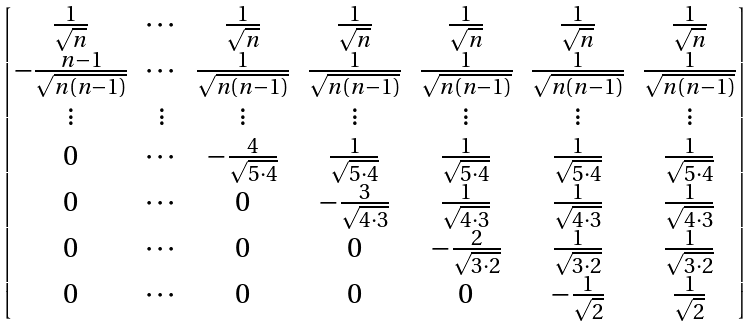<formula> <loc_0><loc_0><loc_500><loc_500>\begin{bmatrix} \frac { 1 } { \sqrt { n } } & \cdots & \frac { 1 } { \sqrt { n } } & \frac { 1 } { \sqrt { n } } & \frac { 1 } { \sqrt { n } } & \frac { 1 } { \sqrt { n } } & \frac { 1 } { \sqrt { n } } \\ - \frac { n - 1 } { \sqrt { n ( n - 1 ) } } & \cdots & \frac { 1 } { \sqrt { n ( n - 1 ) } } & \frac { 1 } { \sqrt { n ( n - 1 ) } } & \frac { 1 } { \sqrt { n ( n - 1 ) } } & \frac { 1 } { \sqrt { n ( n - 1 ) } } & \frac { 1 } { \sqrt { n ( n - 1 ) } } \\ \vdots & \vdots & \vdots & \vdots & \vdots & \vdots & \vdots \\ 0 & \cdots & - \frac { 4 } { \sqrt { 5 \cdot 4 } } & \frac { 1 } { \sqrt { 5 \cdot 4 } } & \frac { 1 } { \sqrt { 5 \cdot 4 } } & \frac { 1 } { \sqrt { 5 \cdot 4 } } & \frac { 1 } { \sqrt { 5 \cdot 4 } } \\ 0 & \cdots & 0 & - \frac { 3 } { \sqrt { 4 \cdot 3 } } & \frac { 1 } { \sqrt { 4 \cdot 3 } } & \frac { 1 } { \sqrt { 4 \cdot 3 } } & \frac { 1 } { \sqrt { 4 \cdot 3 } } \\ 0 & \cdots & 0 & 0 & - \frac { 2 } { \sqrt { 3 \cdot 2 } } & \frac { 1 } { \sqrt { 3 \cdot 2 } } & \frac { 1 } { \sqrt { 3 \cdot 2 } } \\ 0 & \cdots & 0 & 0 & 0 & - \frac { 1 } { \sqrt { 2 } } & \frac { 1 } { \sqrt { 2 } } \end{bmatrix}</formula> 